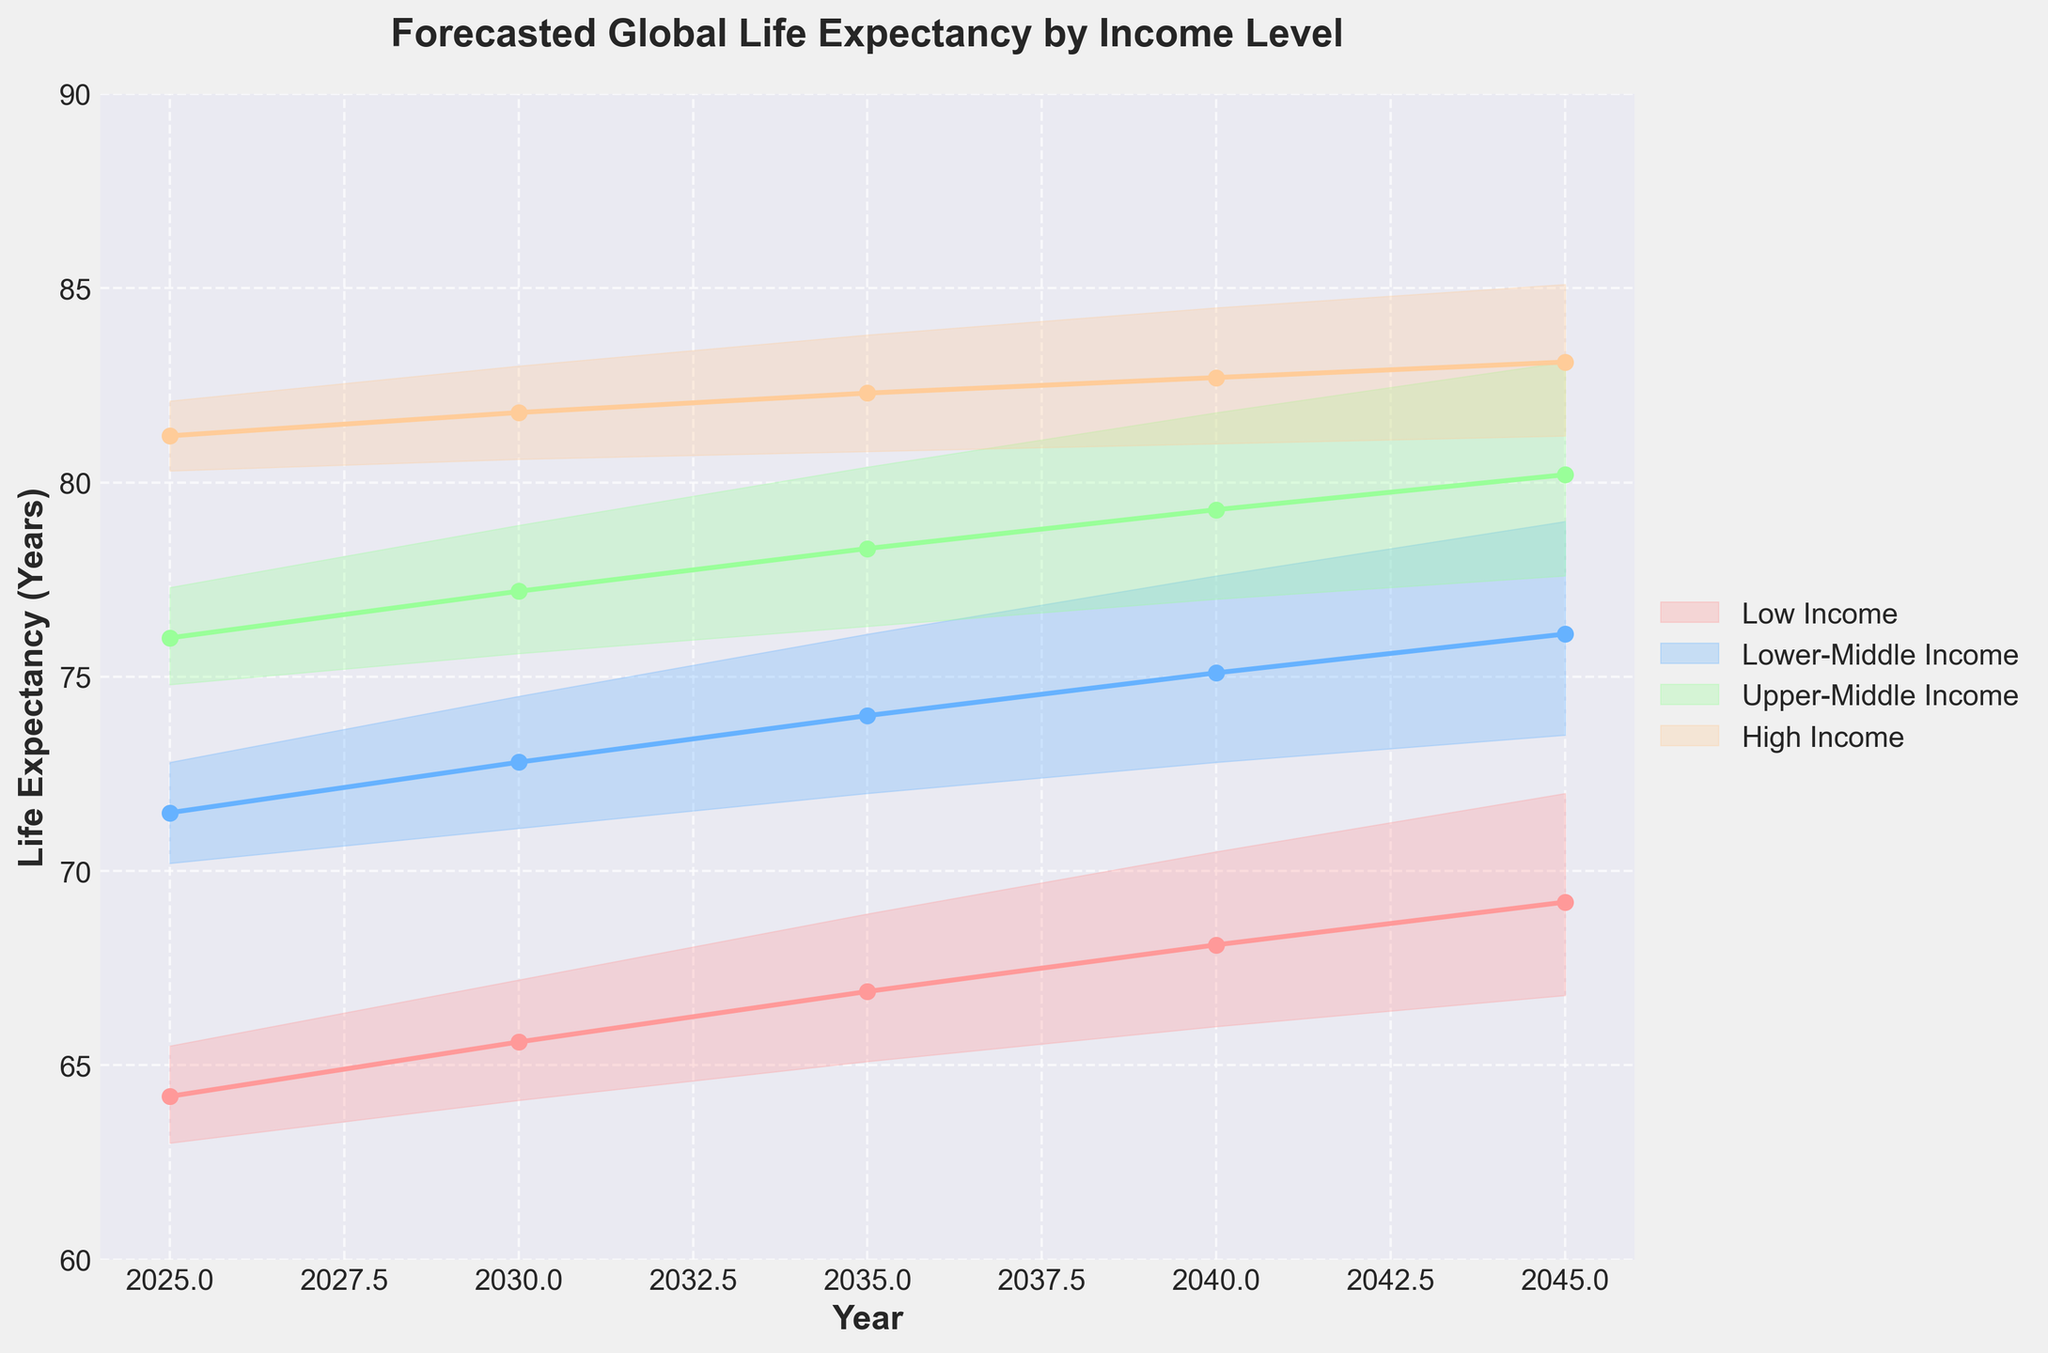What is the title of the figure? The title of the figure is written at the top and usually describes what the figure is about. In this case, it reads "Forecasted Global Life Expectancy by Income Level".
Answer: Forecasted Global Life Expectancy by Income Level How many different income levels are represented in the figure? By observing the legend on the right side of the figure, we can see that there are four different income levels listed: Low Income, Lower-Middle Income, Upper-Middle Income, and High Income.
Answer: Four What are the three scenarios considered in the figure? The different scenarios are represented by the filled areas and baseline lines, labeled in the legend. The scenarios are 'Optimistic', 'Baseline', and 'Pessimistic'.
Answer: Optimistic, Baseline, Pessimistic Which income level has the highest baseline life expectancy in 2045? By looking at the end points of the baseline lines in 2045 on the x-axis, we can see the highest value is associated with the High Income level.
Answer: High Income What is the trend in life expectancy for the Low Income level across all scenarios? The trend can be observed by looking at the filled areas and baseline lines from 2025 to 2045 for the Low Income level. The life expectancy generally increases in all scenarios.
Answer: Increasing What is the difference in baseline life expectancy between High Income and Low Income in 2035? The baseline life expectancy for High Income in 2035 is around 82.3, and for Low Income, it is around 66.9. The difference is 82.3 - 66.9 = 15.4 years.
Answer: 15.4 years Which scenario shows the widest range of life expectancy in 2040 for Upper-Middle Income? In 2040, for Upper-Middle Income, the difference between the optimistic (81.8) and pessimistic (77.0) scenarios is the range. For the given year, Upper-Middle Income has a range of 81.8 - 77.0 = 4.8 years.
Answer: 4.8 years How does the trend in life expectancy for Lower-Middle Income under the optimistic scenario compare to the baseline scenario from 2025 to 2045? By observing the filled areas and lines, we see that the life expectancy under the optimistic scenario shows a steeper and more continuous increase compared to the baseline scenario, which also increases but at a slower rate.
Answer: Optimistic scenario increases faster Which income level shows the smallest range between the pessimistic and optimistic scenarios consistently from 2025 to 2045? By comparing the filled areas for each income level over all the years, High Income has the smallest range between the pessimistic and optimistic scenarios consistently.
Answer: High Income In 2030, what is the difference between optimistic and pessimistic life expectancy for Lower-Middle Income? For the year 2030, the optimistic life expectancy for Lower-Middle Income is 74.5, and the pessimistic life expectancy is 71.1. The difference is 74.5 - 71.1 = 3.4 years.
Answer: 3.4 years 